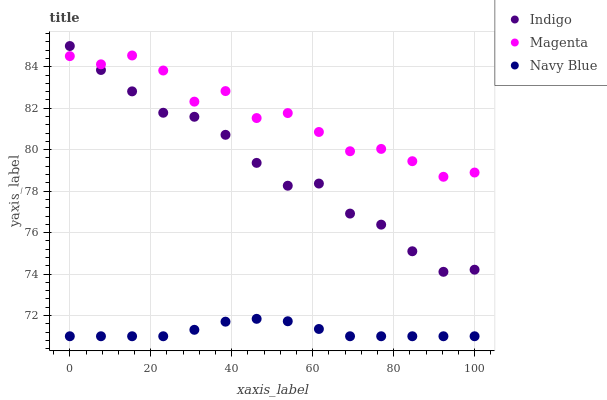Does Navy Blue have the minimum area under the curve?
Answer yes or no. Yes. Does Magenta have the maximum area under the curve?
Answer yes or no. Yes. Does Indigo have the minimum area under the curve?
Answer yes or no. No. Does Indigo have the maximum area under the curve?
Answer yes or no. No. Is Navy Blue the smoothest?
Answer yes or no. Yes. Is Magenta the roughest?
Answer yes or no. Yes. Is Indigo the smoothest?
Answer yes or no. No. Is Indigo the roughest?
Answer yes or no. No. Does Navy Blue have the lowest value?
Answer yes or no. Yes. Does Indigo have the lowest value?
Answer yes or no. No. Does Indigo have the highest value?
Answer yes or no. Yes. Does Magenta have the highest value?
Answer yes or no. No. Is Navy Blue less than Indigo?
Answer yes or no. Yes. Is Indigo greater than Navy Blue?
Answer yes or no. Yes. Does Indigo intersect Magenta?
Answer yes or no. Yes. Is Indigo less than Magenta?
Answer yes or no. No. Is Indigo greater than Magenta?
Answer yes or no. No. Does Navy Blue intersect Indigo?
Answer yes or no. No. 